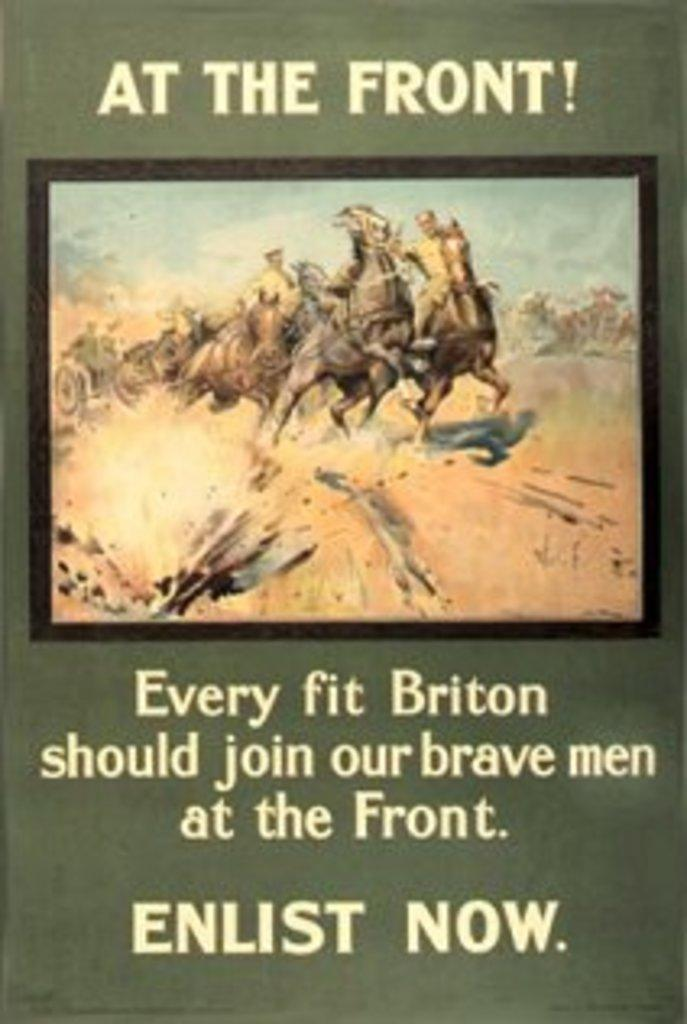<image>
Give a short and clear explanation of the subsequent image. A war poster that says "At the Front" and "Enlist Now." 